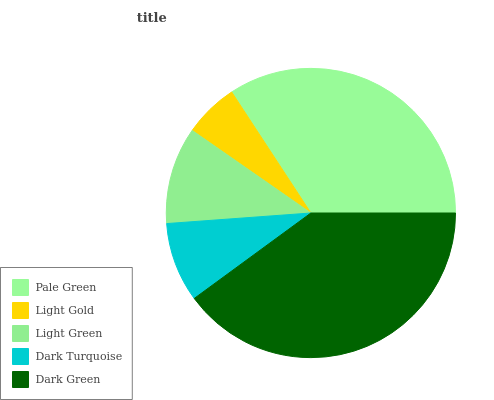Is Light Gold the minimum?
Answer yes or no. Yes. Is Dark Green the maximum?
Answer yes or no. Yes. Is Light Green the minimum?
Answer yes or no. No. Is Light Green the maximum?
Answer yes or no. No. Is Light Green greater than Light Gold?
Answer yes or no. Yes. Is Light Gold less than Light Green?
Answer yes or no. Yes. Is Light Gold greater than Light Green?
Answer yes or no. No. Is Light Green less than Light Gold?
Answer yes or no. No. Is Light Green the high median?
Answer yes or no. Yes. Is Light Green the low median?
Answer yes or no. Yes. Is Dark Green the high median?
Answer yes or no. No. Is Dark Turquoise the low median?
Answer yes or no. No. 